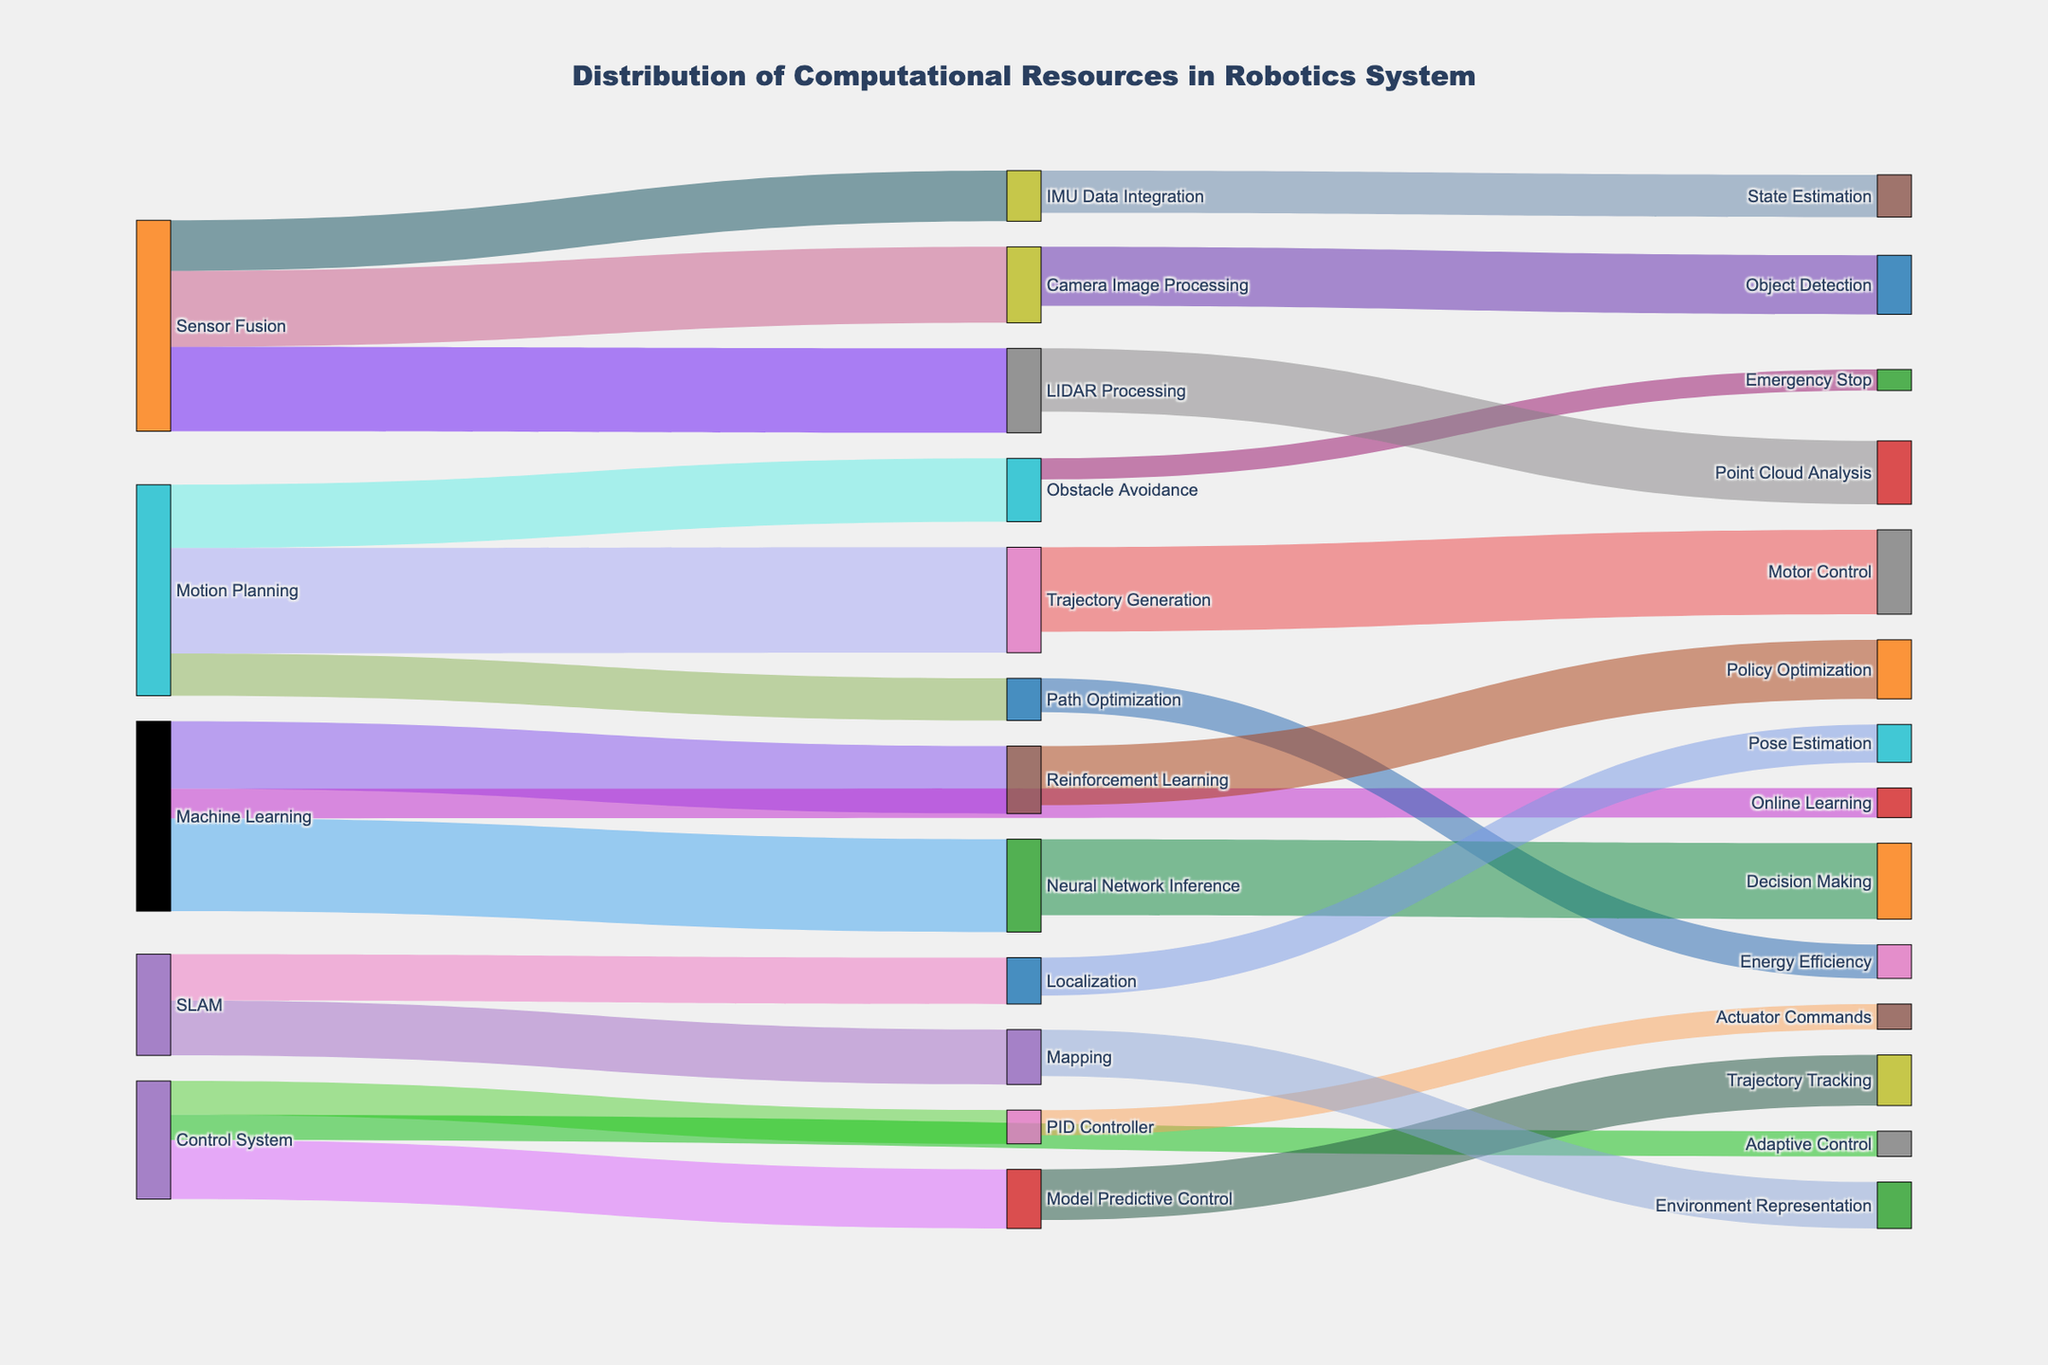What's the title of the Sankey Diagram? The title is usually displayed prominently at the top of the figure.
Answer: Distribution of Computational Resources in Robotics System Which module has the highest allocation of computational resources and what are its total resources? Look for the source node with the highest values flowing out. Sum the values for this node.
Answer: Motion Planning, 50 How many target nodes does the Sensor Fusion module distribute resources to, and what are they? Identify the target nodes connected to 'Sensor Fusion'. Count these nodes and list them.
Answer: 3 targets: LIDAR Processing, Camera Image Processing, IMU Data Integration Compare the resources allocated to Trajectory Generation and Path Optimization from Motion Planning. Which receives more? Observe the links from Motion Planning to Trajectory Generation and Path Optimization. Compare their values.
Answer: Trajectory Generation, 25 vs 10 What is the total computational resource allocated to the SLAM module? Sum the values flowing out of the SLAM source node.
Answer: 24 What is the smallest allocation from Machine Learning to its targets, and which target does it correspond to? Identify the links from Machine Learning to its targets and find the minimum value. Note the target node.
Answer: Online Learning, 7 Which path has the lowest computational resource allocation in the entire system? Look for the link with the lowest value among all paths.
Answer: Obstacle Avoidance to Emergency Stop, 5 What are the top three modules receiving the highest computational resources? Observe all target nodes and sum up their incoming values. Identify the top three.
Answer: Motor Control (20), Decision Making (18), Point Cloud Analysis (15) Find the total allocation for Controller-related processes and how do they compare to Machine Learning allocations. Sum allocations to PID Controller, Model Predictive Control, and Adaptive Control. Compare with the sum of Machine Learning distributions.
Answer: Control System: 8 + 14 + 6 = 28, Machine Learning: 22 + 16 + 7 = 45 Which target node receives resources from the highest number of different source modules? Identify the node with the highest number of incoming links from different sources.
Answer: Motor Control, 1 source: Trajectory Generation 